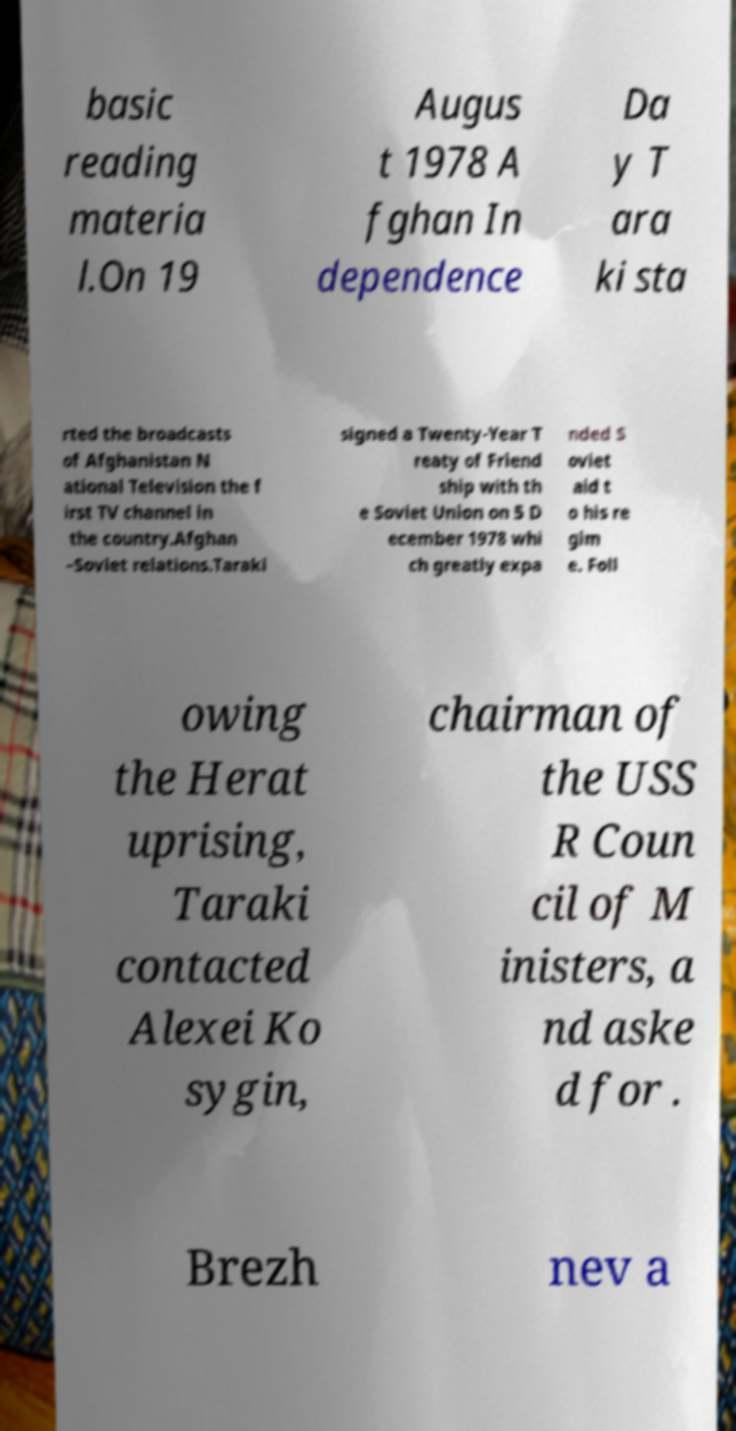Could you assist in decoding the text presented in this image and type it out clearly? basic reading materia l.On 19 Augus t 1978 A fghan In dependence Da y T ara ki sta rted the broadcasts of Afghanistan N ational Television the f irst TV channel in the country.Afghan –Soviet relations.Taraki signed a Twenty-Year T reaty of Friend ship with th e Soviet Union on 5 D ecember 1978 whi ch greatly expa nded S oviet aid t o his re gim e. Foll owing the Herat uprising, Taraki contacted Alexei Ko sygin, chairman of the USS R Coun cil of M inisters, a nd aske d for . Brezh nev a 